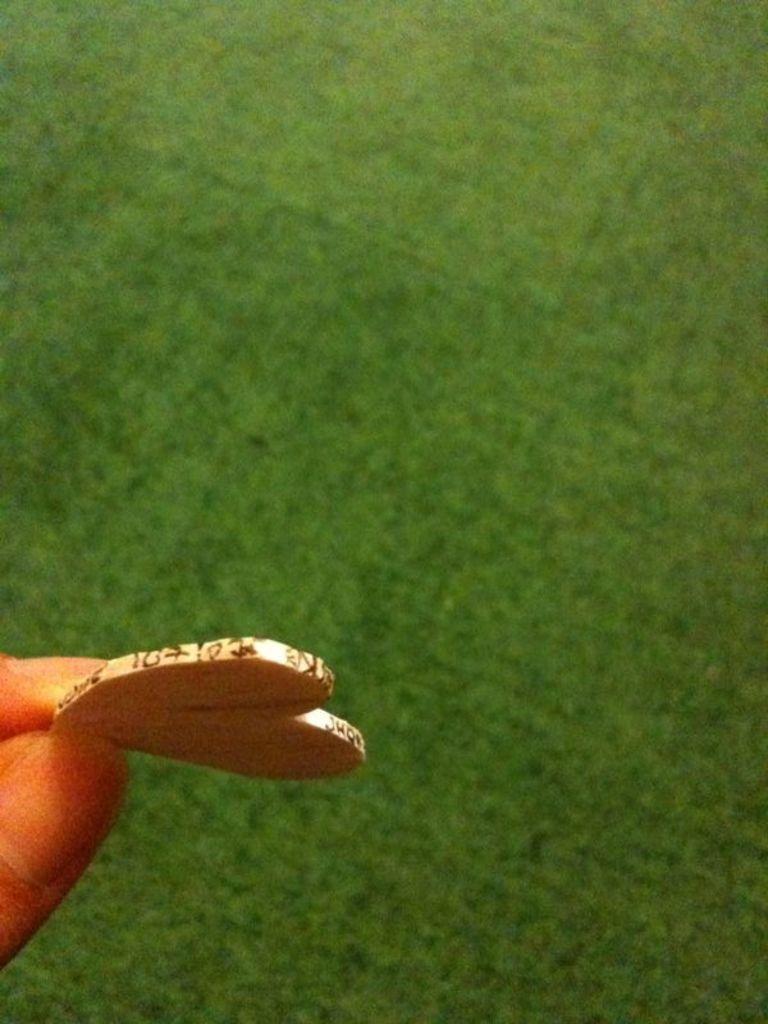How would you summarize this image in a sentence or two? In this image on the left side of there is the hand of the person holding an object and in the center there is grass on the ground. 